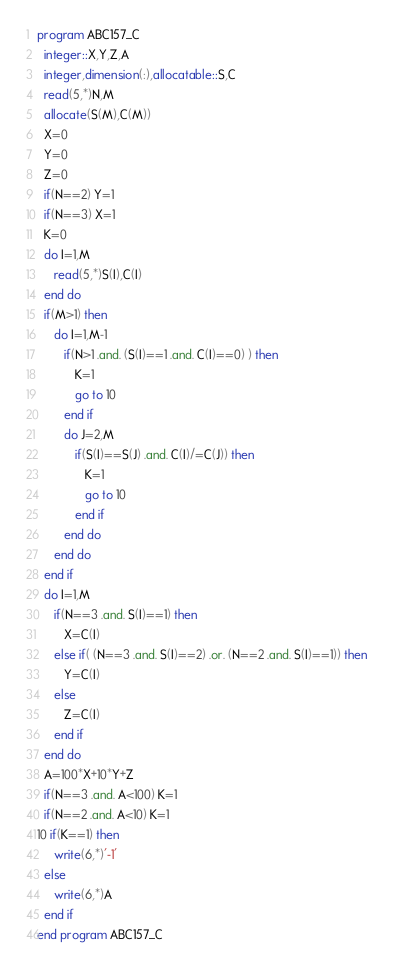Convert code to text. <code><loc_0><loc_0><loc_500><loc_500><_FORTRAN_>program ABC157_C
  integer::X,Y,Z,A
  integer,dimension(:),allocatable::S,C
  read(5,*)N,M
  allocate(S(M),C(M))
  X=0
  Y=0
  Z=0
  if(N==2) Y=1
  if(N==3) X=1
  K=0
  do I=1,M
     read(5,*)S(I),C(I)
  end do
  if(M>1) then
     do I=1,M-1
        if(N>1 .and. (S(I)==1 .and. C(I)==0) ) then
           K=1
           go to 10
        end if
        do J=2,M
           if(S(I)==S(J) .and. C(I)/=C(J)) then
              K=1
              go to 10
           end if
        end do
     end do
  end if
  do I=1,M
     if(N==3 .and. S(I)==1) then
        X=C(I)
     else if( (N==3 .and. S(I)==2) .or. (N==2 .and. S(I)==1)) then
        Y=C(I)
     else
        Z=C(I)
     end if
  end do
  A=100*X+10*Y+Z
  if(N==3 .and. A<100) K=1
  if(N==2 .and. A<10) K=1
10 if(K==1) then
     write(6,*)'-1'
  else
     write(6,*)A
  end if
end program ABC157_C</code> 